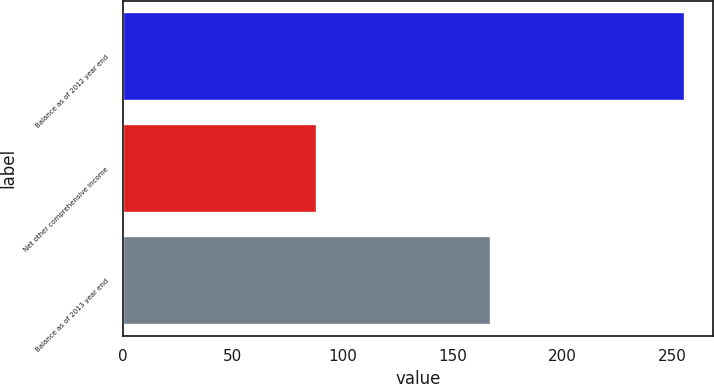<chart> <loc_0><loc_0><loc_500><loc_500><bar_chart><fcel>Balance as of 2012 year end<fcel>Net other comprehensive income<fcel>Balance as of 2013 year end<nl><fcel>255.6<fcel>88.4<fcel>167.2<nl></chart> 